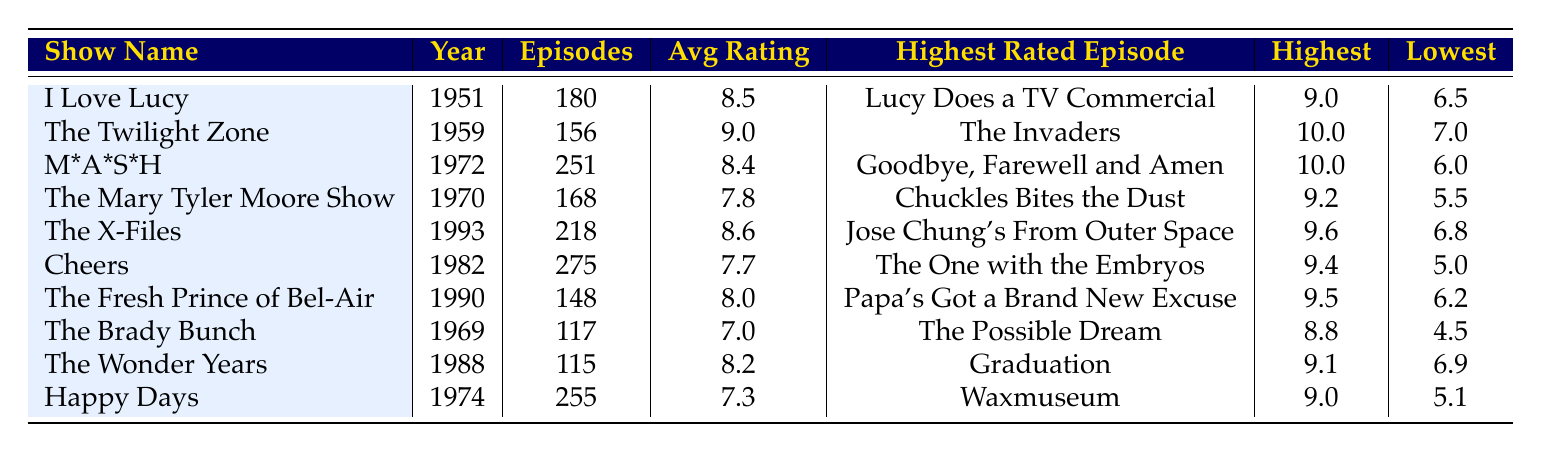What is the average rating of "The Mary Tyler Moore Show"? The table shows that "The Mary Tyler Moore Show" has an average rating of 7.8. This value is directly retrieved from the column labeled "Avg Rating" for that show.
Answer: 7.8 Which show has the highest average rating? From the table, "The Twilight Zone" has the highest average rating of 9.0. It can be found by comparing all the values under "Avg Rating" and identifying the largest one.
Answer: The Twilight Zone How many episodes does "M*A*S*H" have? The table indicates that "M*A*S*H" has a total of 251 episodes, directly found in the "Episodes" column for that show.
Answer: 251 Is it true that "Happy Days" has a lower average rating than "Cheers"? By comparing the average ratings, "Happy Days" has an average rating of 7.3 while "Cheers" has 7.7. Since 7.3 is less than 7.7, the statement is true.
Answer: Yes What is the difference between the highest and the lowest rating of "The X-Files"? "The X-Files" has a highest rating of 9.6 and a lowest rating of 6.8. To find the difference, subtract the lowest rating from the highest rating: 9.6 - 6.8 = 2.8.
Answer: 2.8 Which show has the highest rated episode titled "Goodbye, Farewell and Amen"? The table shows that "Goodbye, Farewell and Amen" is the highest rated episode of "M*A*S*H." This information is found under the "Highest Rated Episode" column corresponding to that show.
Answer: M*A*S*H If we were to average the average ratings of shows from the 1970s, what would that be? For the shows listed in the 1970s ("The Mary Tyler Moore Show," "M*A*S*H," and "Happy Days"), the average ratings are 7.8, 8.4, and 7.3, respectively. Summing these gives 23.5, and dividing by 3 (the number of shows) results in an average rating of approximately 7.83.
Answer: 7.83 Who had the lowest rated episode in the table? The "lowest rating" for the shows listed shows that "The Brady Bunch" has the lowest at a score of 4.5, as seen in the "Lowest" column for that show.
Answer: The Brady Bunch 